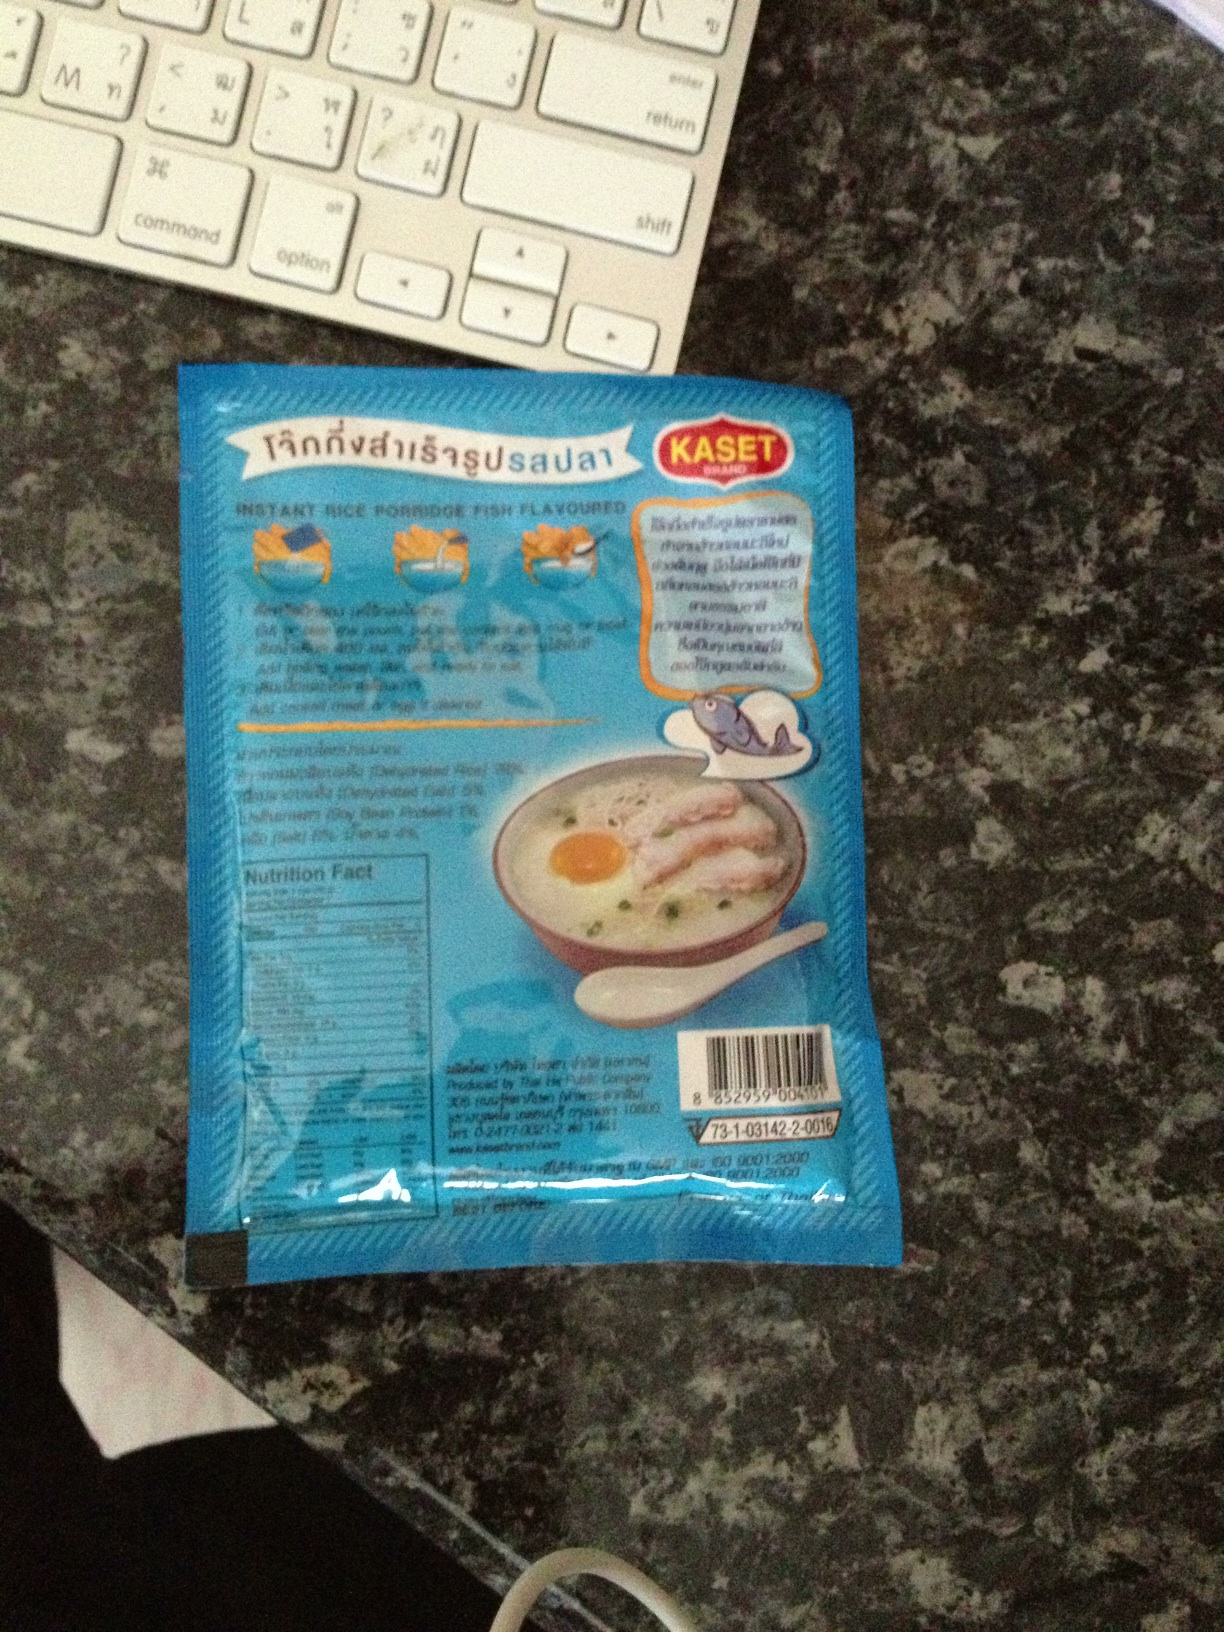What is it? This appears to be a packaged food product, specifically an instant rice porridge with fish flavor as indicated by the packaging. 